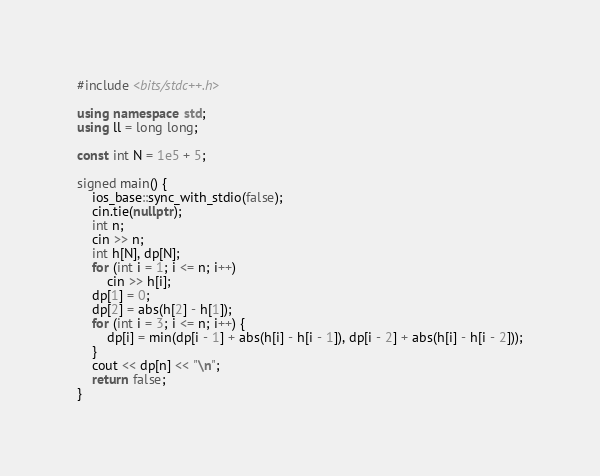<code> <loc_0><loc_0><loc_500><loc_500><_C++_>#include <bits/stdc++.h>

using namespace std;
using ll = long long;

const int N = 1e5 + 5;

signed main() {
    ios_base::sync_with_stdio(false); 
    cin.tie(nullptr);
    int n;
    cin >> n;
    int h[N], dp[N];
    for (int i = 1; i <= n; i++) 
        cin >> h[i];
    dp[1] = 0;
    dp[2] = abs(h[2] - h[1]);
    for (int i = 3; i <= n; i++) {
        dp[i] = min(dp[i - 1] + abs(h[i] - h[i - 1]), dp[i - 2] + abs(h[i] - h[i - 2]));
    }
    cout << dp[n] << "\n"; 
    return false;
}                                                                     </code> 